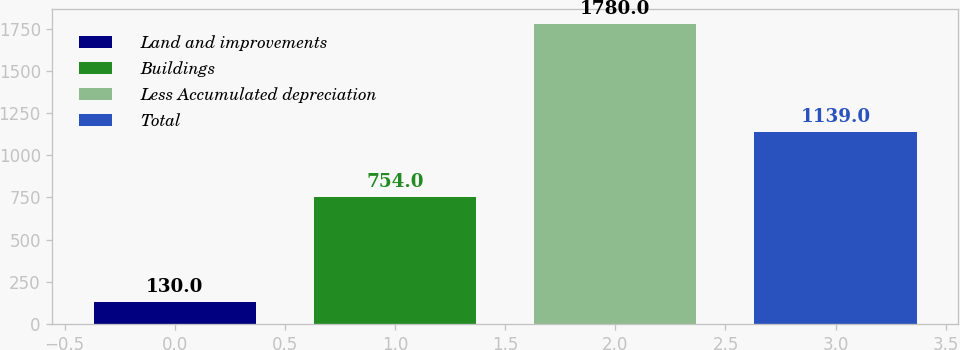<chart> <loc_0><loc_0><loc_500><loc_500><bar_chart><fcel>Land and improvements<fcel>Buildings<fcel>Less Accumulated depreciation<fcel>Total<nl><fcel>130<fcel>754<fcel>1780<fcel>1139<nl></chart> 